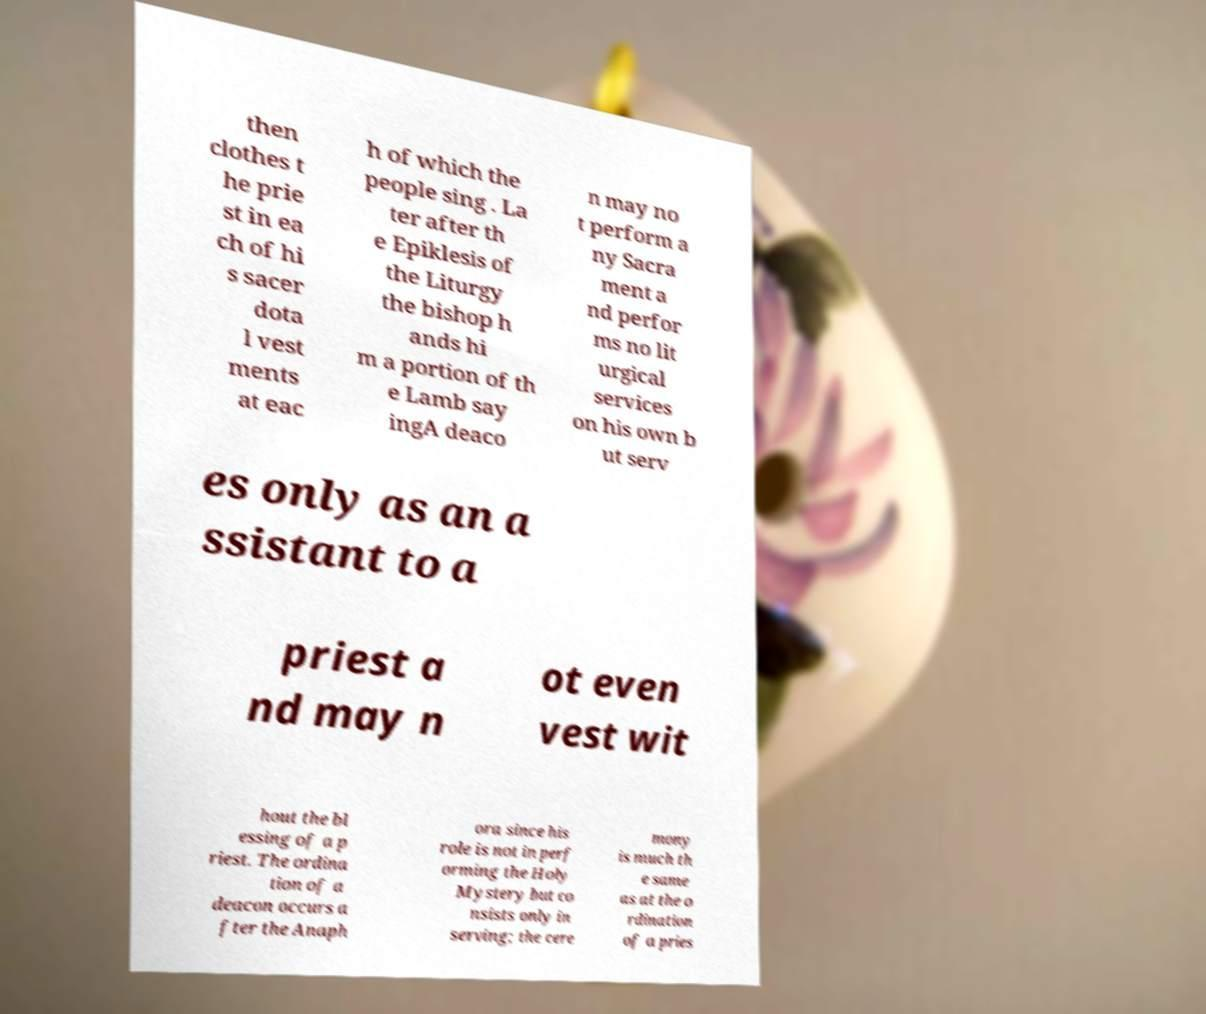Can you accurately transcribe the text from the provided image for me? then clothes t he prie st in ea ch of hi s sacer dota l vest ments at eac h of which the people sing . La ter after th e Epiklesis of the Liturgy the bishop h ands hi m a portion of th e Lamb say ingA deaco n may no t perform a ny Sacra ment a nd perfor ms no lit urgical services on his own b ut serv es only as an a ssistant to a priest a nd may n ot even vest wit hout the bl essing of a p riest. The ordina tion of a deacon occurs a fter the Anaph ora since his role is not in perf orming the Holy Mystery but co nsists only in serving; the cere mony is much th e same as at the o rdination of a pries 